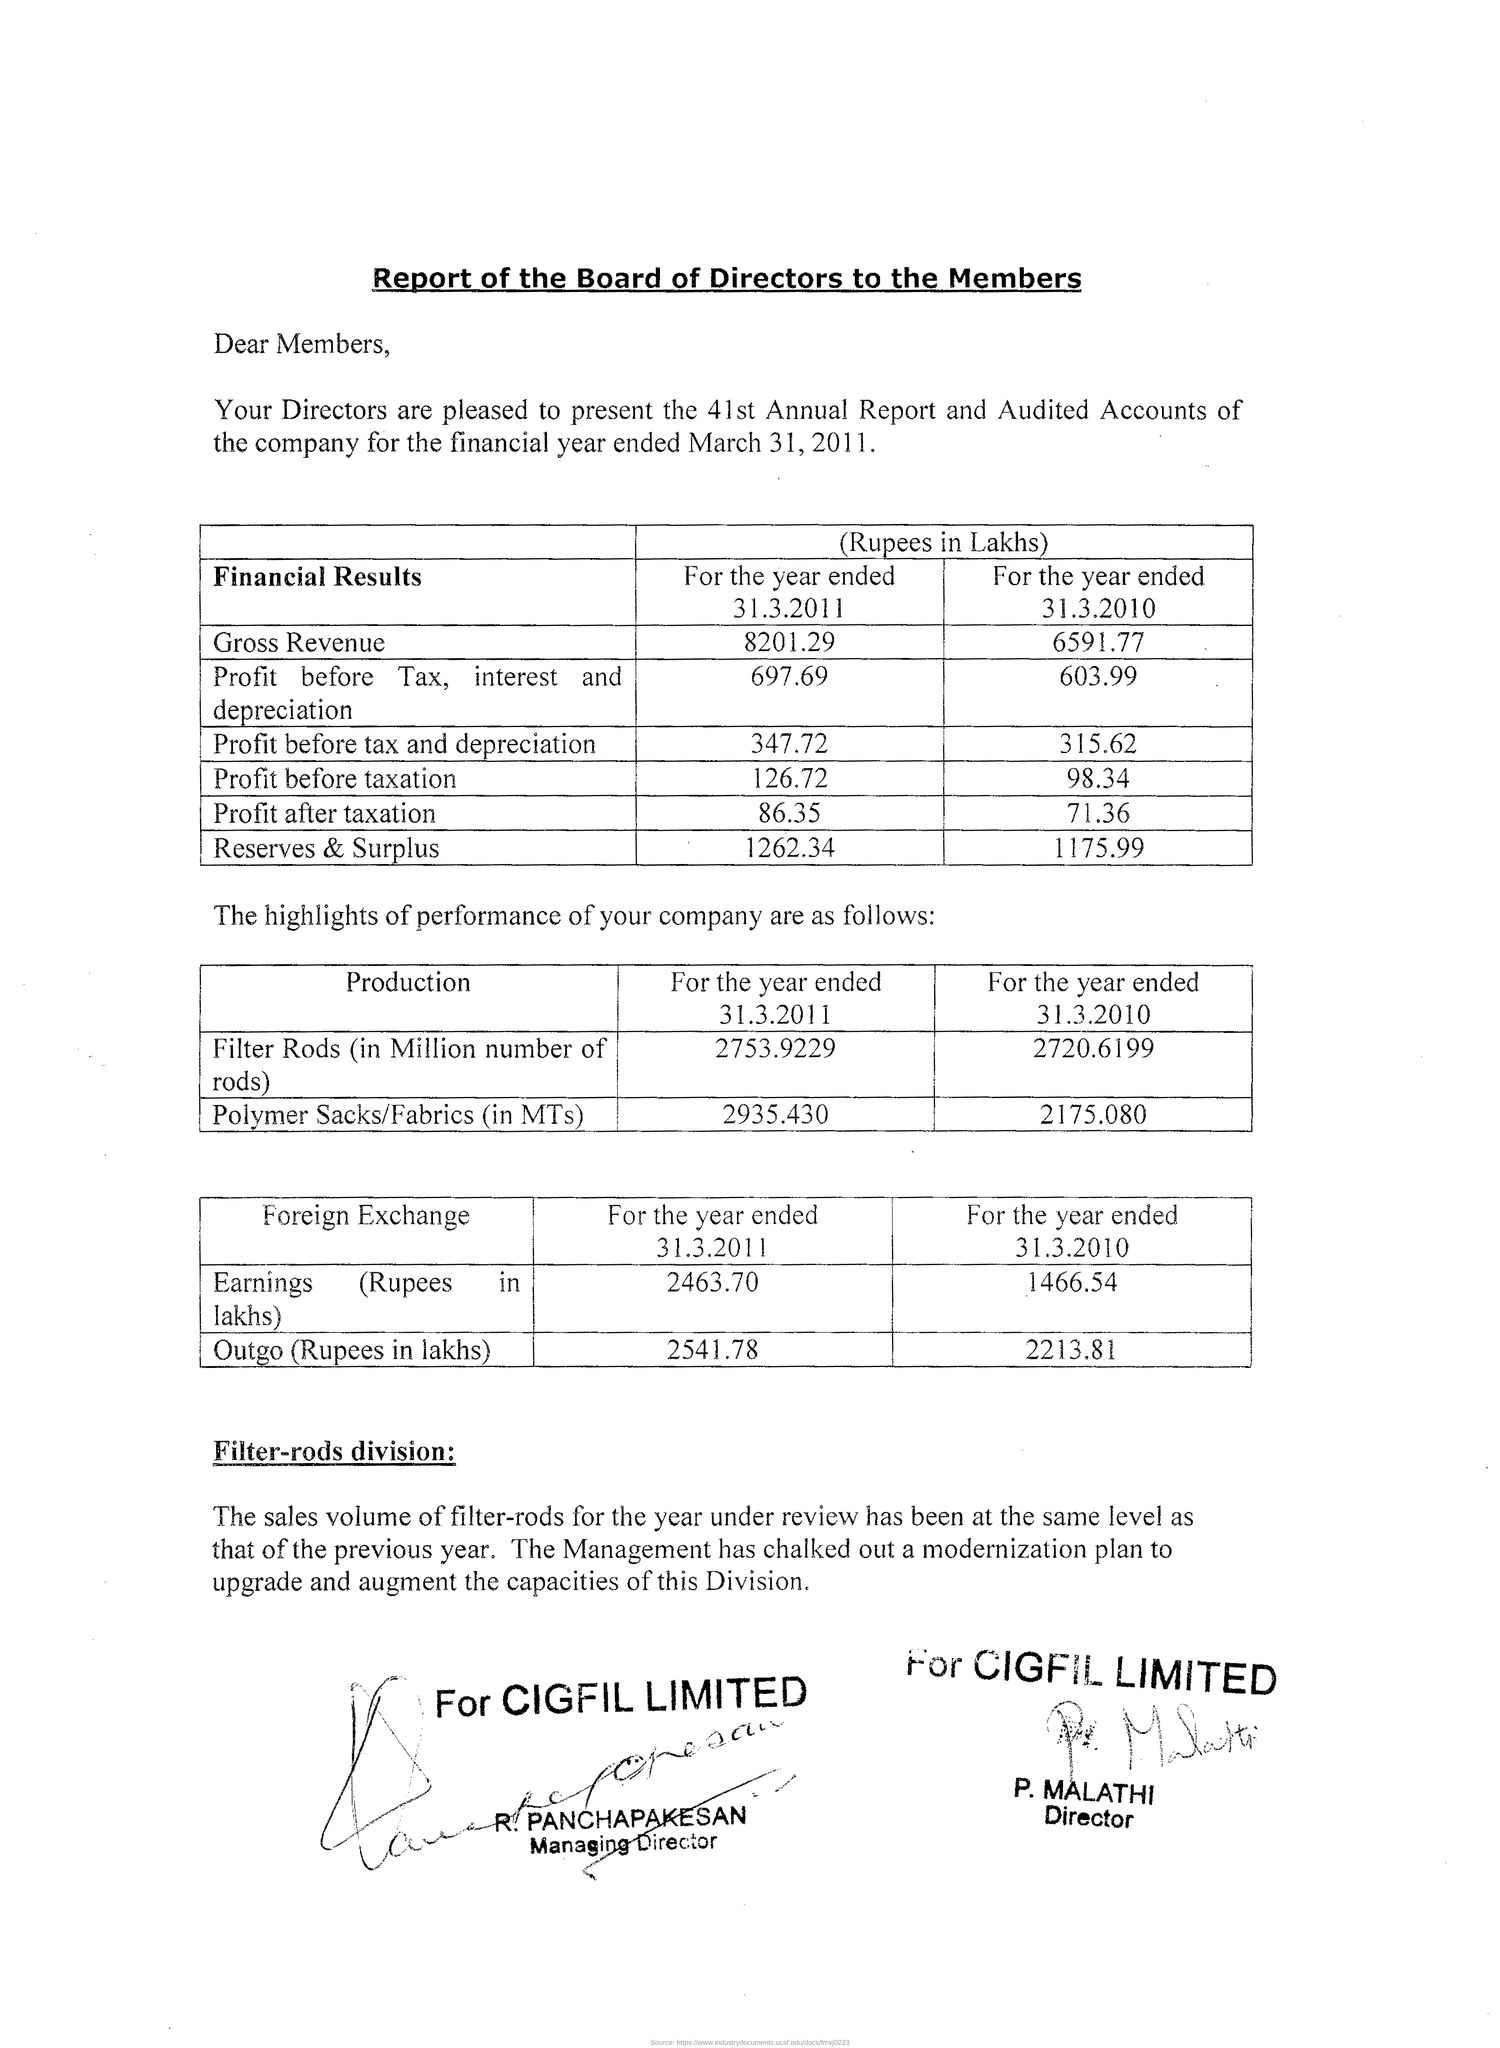Point out several critical features in this image. On March 31st, 2010, the price before taxation was 98.34 dollars. The profit before tax and depreciation for the year 31st March 2010 was 315.62. The gross revenue for the year ended March 31, 2011, was 8201.29 lakhs. The profit before tax and depreciation for the year 31.3.2011 was 347.72. The profit before tax, interest and depreciation for the year 31.3.2011 was 697.69. 